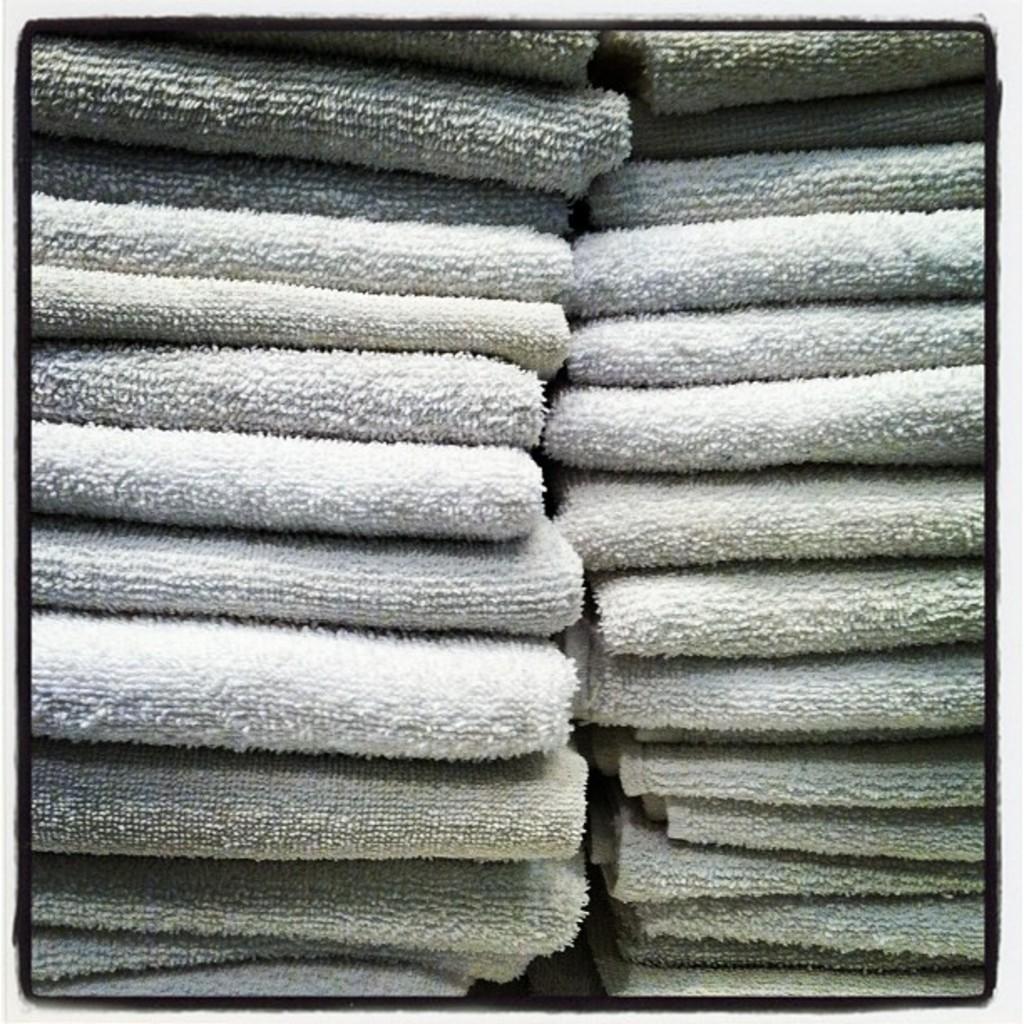Can you describe this image briefly? In this image we can see some towels which are folded. 